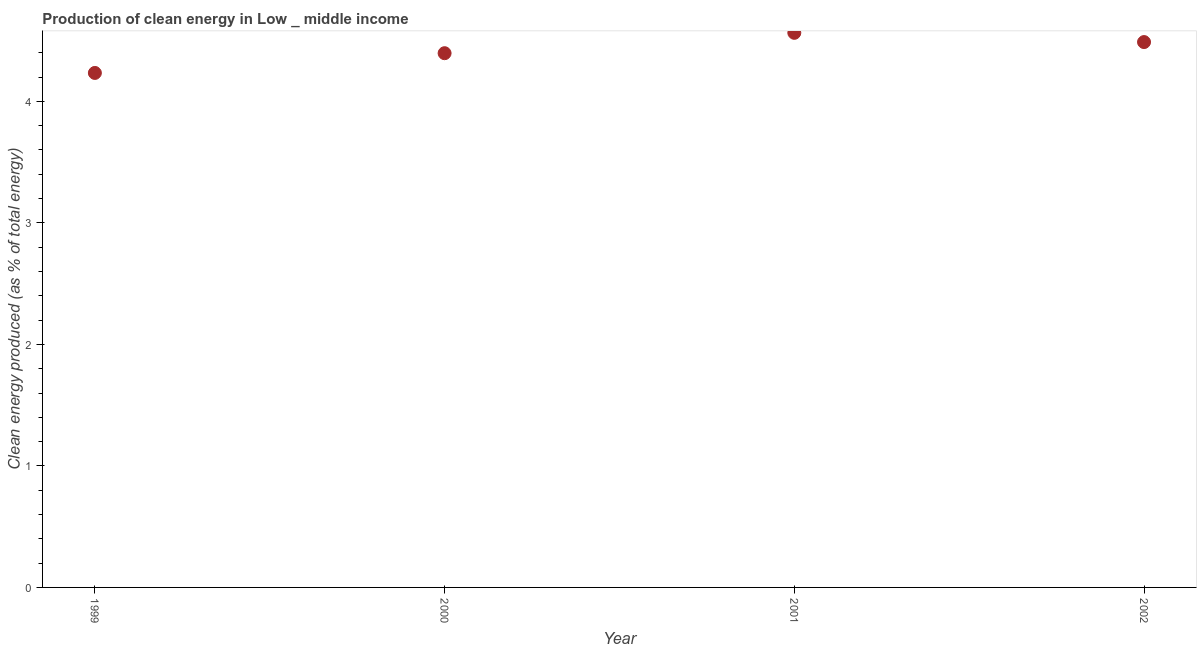What is the production of clean energy in 1999?
Give a very brief answer. 4.23. Across all years, what is the maximum production of clean energy?
Keep it short and to the point. 4.56. Across all years, what is the minimum production of clean energy?
Provide a succinct answer. 4.23. In which year was the production of clean energy maximum?
Your answer should be compact. 2001. What is the sum of the production of clean energy?
Provide a succinct answer. 17.68. What is the difference between the production of clean energy in 1999 and 2000?
Ensure brevity in your answer.  -0.16. What is the average production of clean energy per year?
Provide a short and direct response. 4.42. What is the median production of clean energy?
Offer a terse response. 4.44. In how many years, is the production of clean energy greater than 0.4 %?
Ensure brevity in your answer.  4. What is the ratio of the production of clean energy in 2001 to that in 2002?
Provide a succinct answer. 1.02. Is the production of clean energy in 1999 less than that in 2001?
Ensure brevity in your answer.  Yes. What is the difference between the highest and the second highest production of clean energy?
Provide a succinct answer. 0.08. What is the difference between the highest and the lowest production of clean energy?
Ensure brevity in your answer.  0.33. In how many years, is the production of clean energy greater than the average production of clean energy taken over all years?
Offer a terse response. 2. How many dotlines are there?
Your answer should be compact. 1. Does the graph contain grids?
Offer a very short reply. No. What is the title of the graph?
Provide a succinct answer. Production of clean energy in Low _ middle income. What is the label or title of the X-axis?
Keep it short and to the point. Year. What is the label or title of the Y-axis?
Provide a succinct answer. Clean energy produced (as % of total energy). What is the Clean energy produced (as % of total energy) in 1999?
Offer a very short reply. 4.23. What is the Clean energy produced (as % of total energy) in 2000?
Keep it short and to the point. 4.4. What is the Clean energy produced (as % of total energy) in 2001?
Offer a very short reply. 4.56. What is the Clean energy produced (as % of total energy) in 2002?
Keep it short and to the point. 4.49. What is the difference between the Clean energy produced (as % of total energy) in 1999 and 2000?
Provide a succinct answer. -0.16. What is the difference between the Clean energy produced (as % of total energy) in 1999 and 2001?
Your answer should be compact. -0.33. What is the difference between the Clean energy produced (as % of total energy) in 1999 and 2002?
Ensure brevity in your answer.  -0.25. What is the difference between the Clean energy produced (as % of total energy) in 2000 and 2001?
Your answer should be very brief. -0.17. What is the difference between the Clean energy produced (as % of total energy) in 2000 and 2002?
Offer a terse response. -0.09. What is the difference between the Clean energy produced (as % of total energy) in 2001 and 2002?
Keep it short and to the point. 0.08. What is the ratio of the Clean energy produced (as % of total energy) in 1999 to that in 2001?
Offer a terse response. 0.93. What is the ratio of the Clean energy produced (as % of total energy) in 1999 to that in 2002?
Your answer should be compact. 0.94. What is the ratio of the Clean energy produced (as % of total energy) in 2000 to that in 2001?
Keep it short and to the point. 0.96. What is the ratio of the Clean energy produced (as % of total energy) in 2000 to that in 2002?
Your response must be concise. 0.98. 